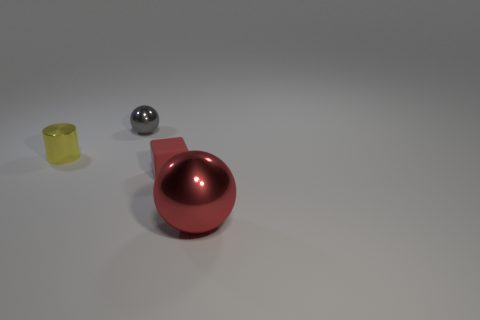What is the shape of the rubber thing that is the same color as the large shiny thing?
Keep it short and to the point. Cube. The ball that is the same color as the small matte block is what size?
Ensure brevity in your answer.  Large. Are there any other things that have the same size as the red metallic thing?
Your response must be concise. No. There is a object that is in front of the tiny red object; what is it made of?
Your answer should be very brief. Metal. There is a metallic object that is on the left side of the ball behind the ball to the right of the gray metal sphere; what is its size?
Keep it short and to the point. Small. Does the cylinder behind the large red shiny ball have the same material as the ball to the left of the large red shiny object?
Make the answer very short. Yes. How many other objects are the same color as the small rubber thing?
Your answer should be compact. 1. How many things are either small things behind the tiny red rubber block or balls that are in front of the tiny yellow metallic object?
Your response must be concise. 3. There is a ball that is in front of the metallic ball that is behind the tiny yellow thing; what is its size?
Ensure brevity in your answer.  Large. What size is the gray shiny ball?
Your answer should be compact. Small. 